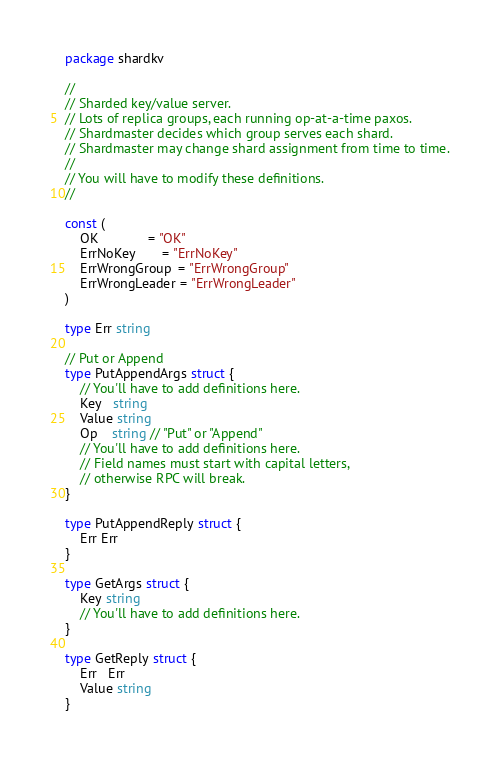<code> <loc_0><loc_0><loc_500><loc_500><_Go_>package shardkv

//
// Sharded key/value server.
// Lots of replica groups, each running op-at-a-time paxos.
// Shardmaster decides which group serves each shard.
// Shardmaster may change shard assignment from time to time.
//
// You will have to modify these definitions.
//

const (
	OK             = "OK"
	ErrNoKey       = "ErrNoKey"
	ErrWrongGroup  = "ErrWrongGroup"
	ErrWrongLeader = "ErrWrongLeader"
)

type Err string

// Put or Append
type PutAppendArgs struct {
	// You'll have to add definitions here.
	Key   string
	Value string
	Op    string // "Put" or "Append"
	// You'll have to add definitions here.
	// Field names must start with capital letters,
	// otherwise RPC will break.
}

type PutAppendReply struct {
	Err Err
}

type GetArgs struct {
	Key string
	// You'll have to add definitions here.
}

type GetReply struct {
	Err   Err
	Value string
}
</code> 